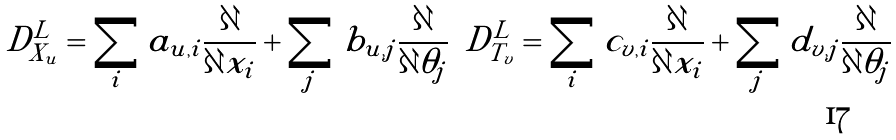<formula> <loc_0><loc_0><loc_500><loc_500>D ^ { L } _ { X _ { u } } & = \sum _ { i } a _ { u , i } \frac { \partial } { \partial x _ { i } } + \sum _ { j } b _ { u , j } \frac { \partial } { \partial \theta _ { j } } & D ^ { L } _ { T _ { v } } & = \sum _ { i } c _ { v , i } \frac { \partial } { \partial x _ { i } } + \sum _ { j } d _ { v , j } \frac { \partial } { \partial \theta _ { j } }</formula> 